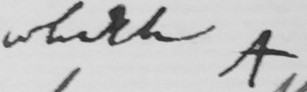What does this handwritten line say? Which A 